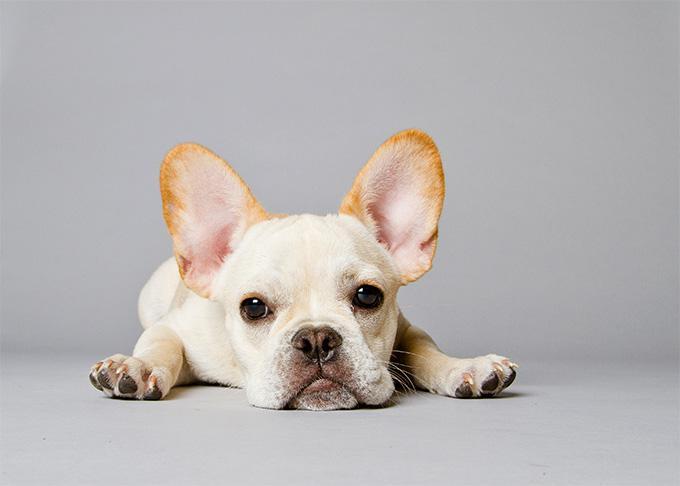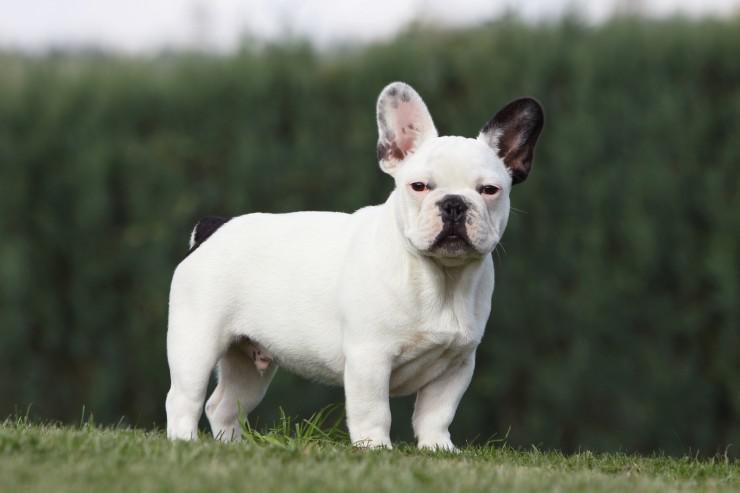The first image is the image on the left, the second image is the image on the right. Examine the images to the left and right. Is the description "At least one dog has black fur on an ear." accurate? Answer yes or no. Yes. 